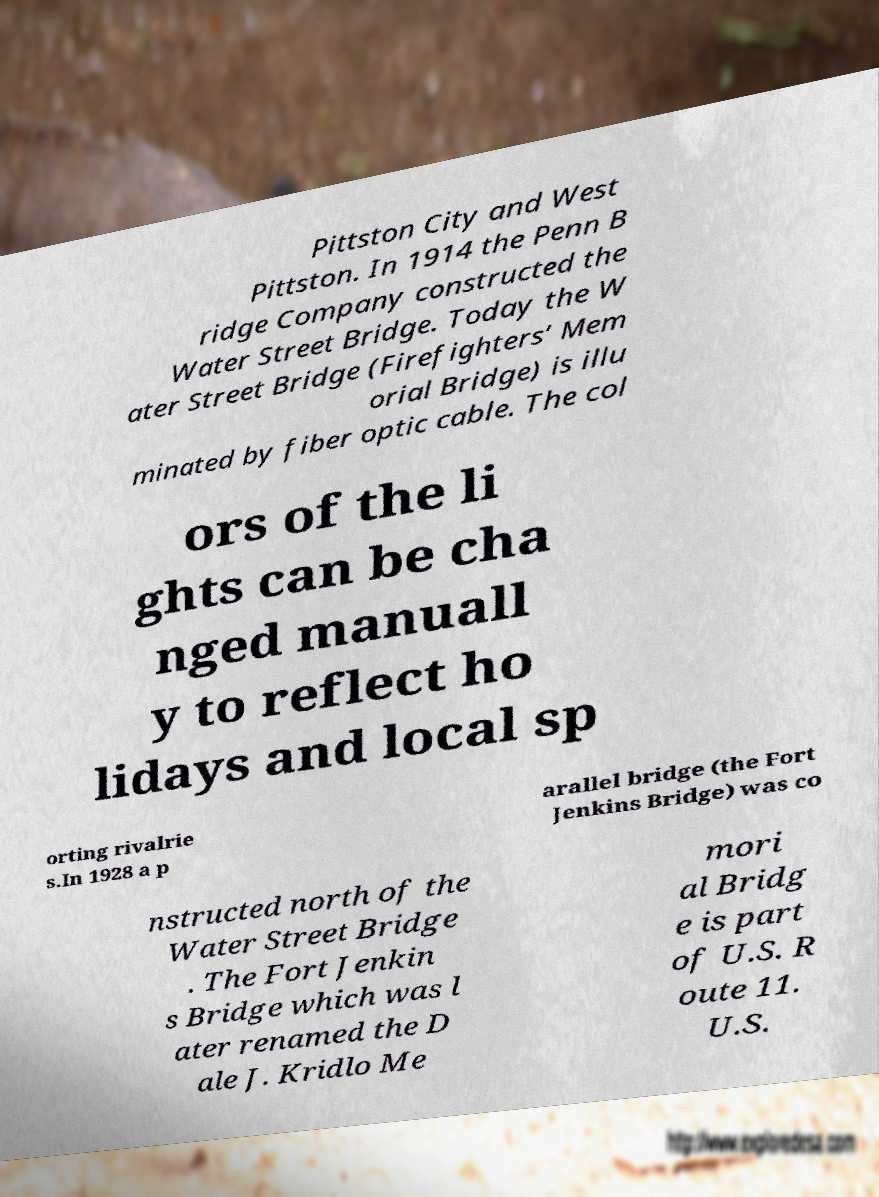Can you accurately transcribe the text from the provided image for me? Pittston City and West Pittston. In 1914 the Penn B ridge Company constructed the Water Street Bridge. Today the W ater Street Bridge (Firefighters’ Mem orial Bridge) is illu minated by fiber optic cable. The col ors of the li ghts can be cha nged manuall y to reflect ho lidays and local sp orting rivalrie s.In 1928 a p arallel bridge (the Fort Jenkins Bridge) was co nstructed north of the Water Street Bridge . The Fort Jenkin s Bridge which was l ater renamed the D ale J. Kridlo Me mori al Bridg e is part of U.S. R oute 11. U.S. 